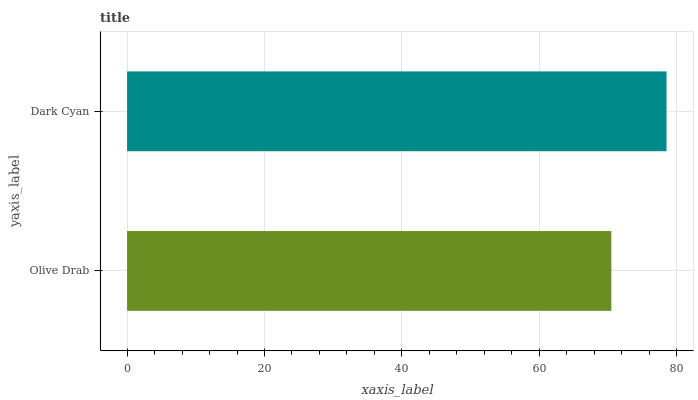Is Olive Drab the minimum?
Answer yes or no. Yes. Is Dark Cyan the maximum?
Answer yes or no. Yes. Is Dark Cyan the minimum?
Answer yes or no. No. Is Dark Cyan greater than Olive Drab?
Answer yes or no. Yes. Is Olive Drab less than Dark Cyan?
Answer yes or no. Yes. Is Olive Drab greater than Dark Cyan?
Answer yes or no. No. Is Dark Cyan less than Olive Drab?
Answer yes or no. No. Is Dark Cyan the high median?
Answer yes or no. Yes. Is Olive Drab the low median?
Answer yes or no. Yes. Is Olive Drab the high median?
Answer yes or no. No. Is Dark Cyan the low median?
Answer yes or no. No. 